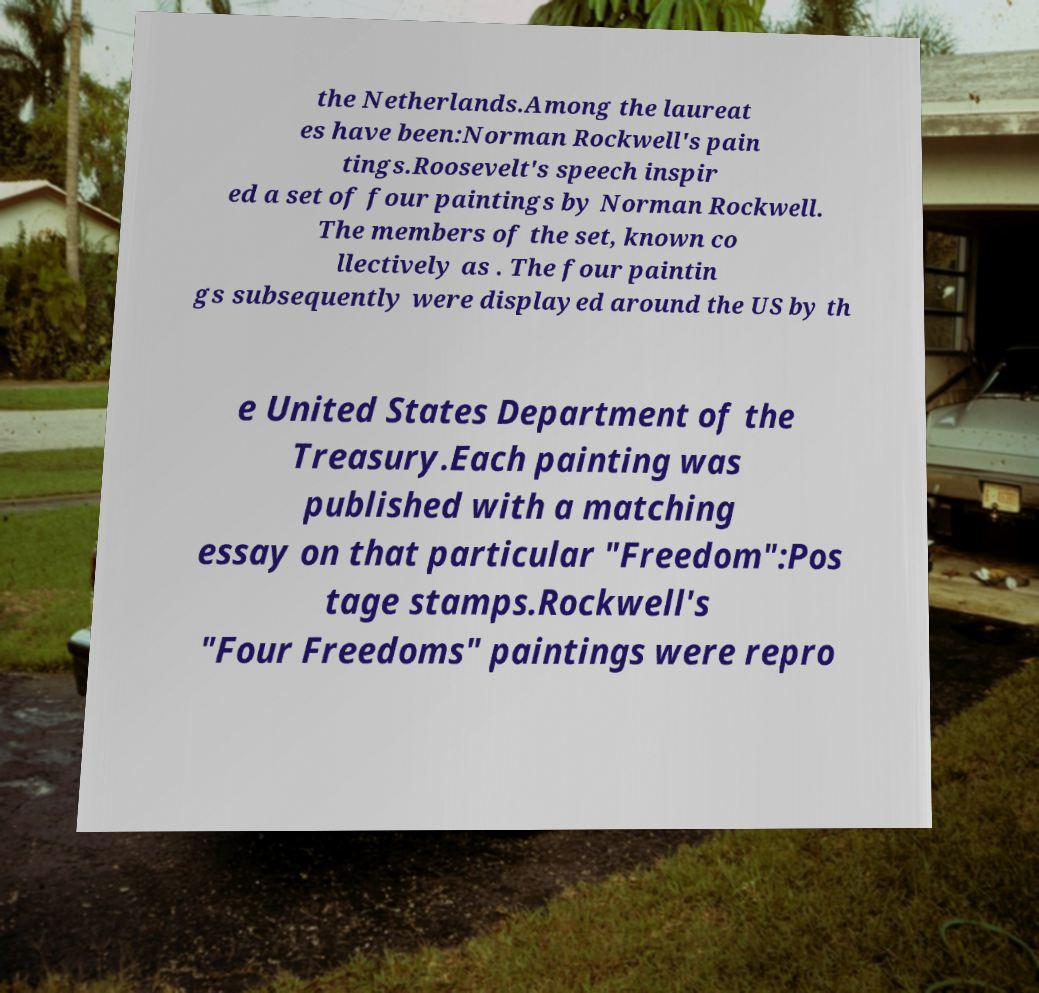I need the written content from this picture converted into text. Can you do that? the Netherlands.Among the laureat es have been:Norman Rockwell's pain tings.Roosevelt's speech inspir ed a set of four paintings by Norman Rockwell. The members of the set, known co llectively as . The four paintin gs subsequently were displayed around the US by th e United States Department of the Treasury.Each painting was published with a matching essay on that particular "Freedom":Pos tage stamps.Rockwell's "Four Freedoms" paintings were repro 